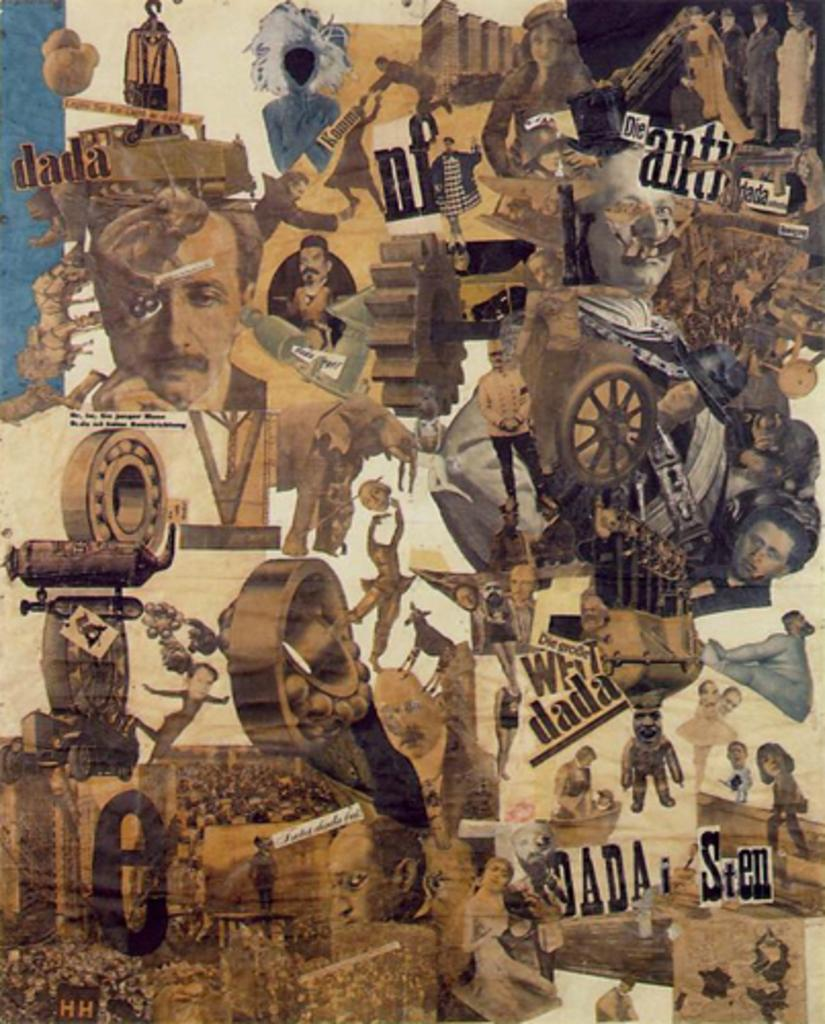What is the main subject of the poster in the image? The poster contains images of people, animals, and a wheel. What else can be found on the poster besides the images? There is text on the poster. What color is the table in the image? There is no table present in the image; it only contains a poster. Is there a fire visible in the image? No, there is no fire visible in the image. 